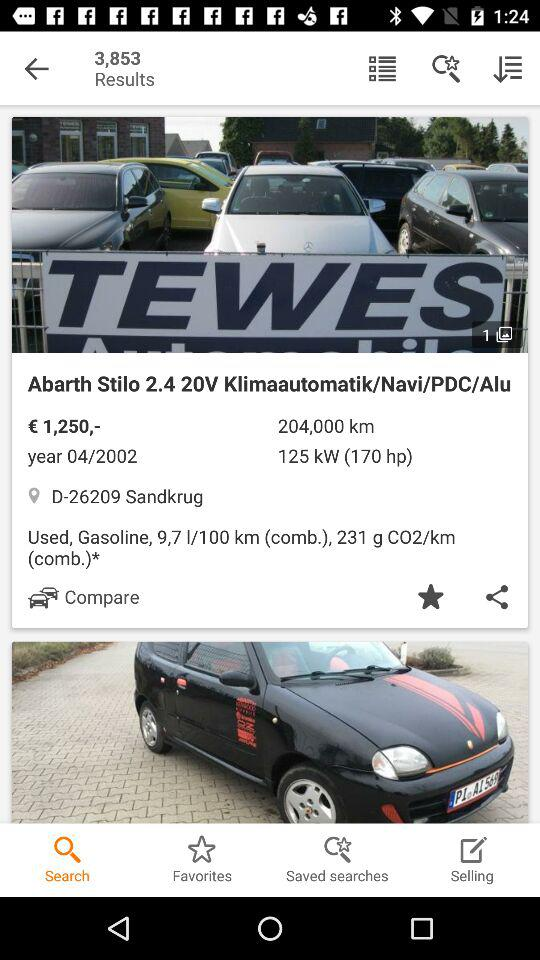How many results are there? There are 3,853 results. 